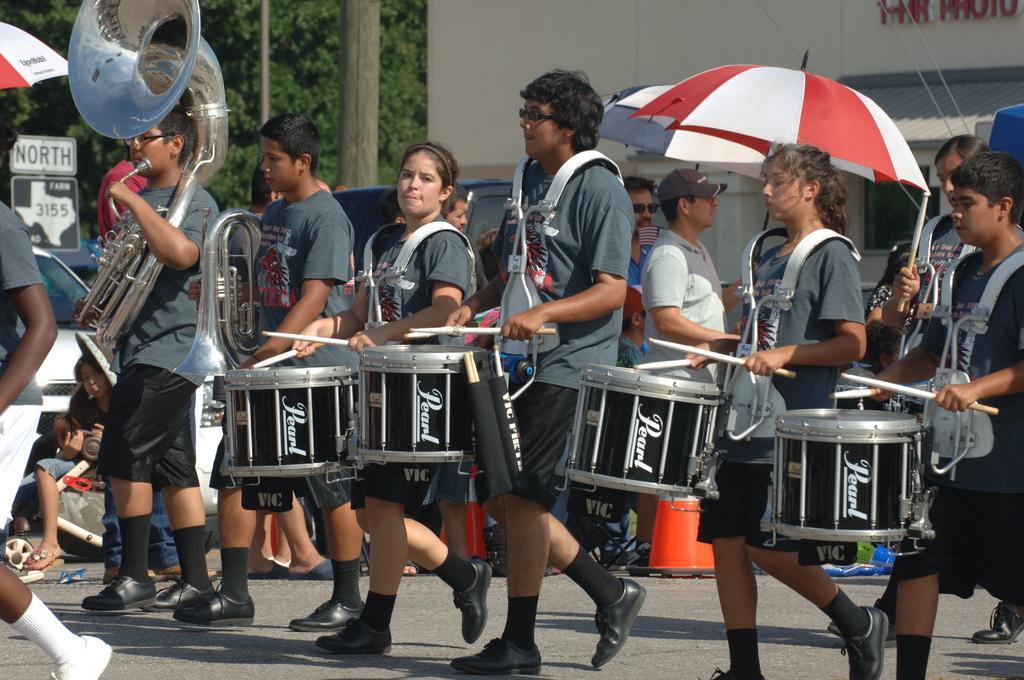Can you describe this image briefly? There are some persons standing and playing drums as we can see in the middle of this image. There are some trees, a vehicle and a building in the background. 